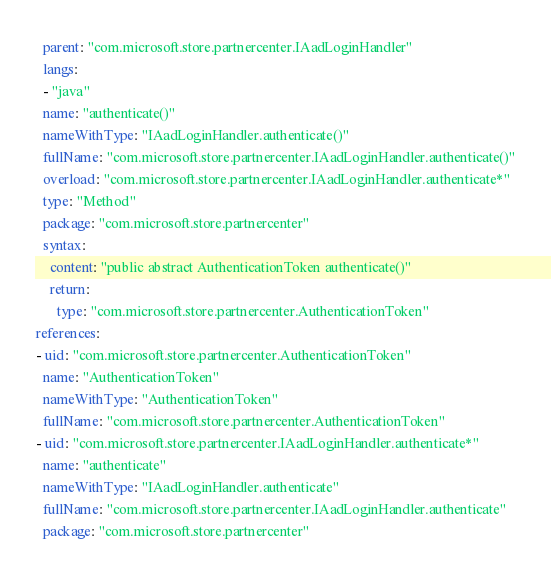<code> <loc_0><loc_0><loc_500><loc_500><_YAML_>  parent: "com.microsoft.store.partnercenter.IAadLoginHandler"
  langs:
  - "java"
  name: "authenticate()"
  nameWithType: "IAadLoginHandler.authenticate()"
  fullName: "com.microsoft.store.partnercenter.IAadLoginHandler.authenticate()"
  overload: "com.microsoft.store.partnercenter.IAadLoginHandler.authenticate*"
  type: "Method"
  package: "com.microsoft.store.partnercenter"
  syntax:
    content: "public abstract AuthenticationToken authenticate()"
    return:
      type: "com.microsoft.store.partnercenter.AuthenticationToken"
references:
- uid: "com.microsoft.store.partnercenter.AuthenticationToken"
  name: "AuthenticationToken"
  nameWithType: "AuthenticationToken"
  fullName: "com.microsoft.store.partnercenter.AuthenticationToken"
- uid: "com.microsoft.store.partnercenter.IAadLoginHandler.authenticate*"
  name: "authenticate"
  nameWithType: "IAadLoginHandler.authenticate"
  fullName: "com.microsoft.store.partnercenter.IAadLoginHandler.authenticate"
  package: "com.microsoft.store.partnercenter"
</code> 